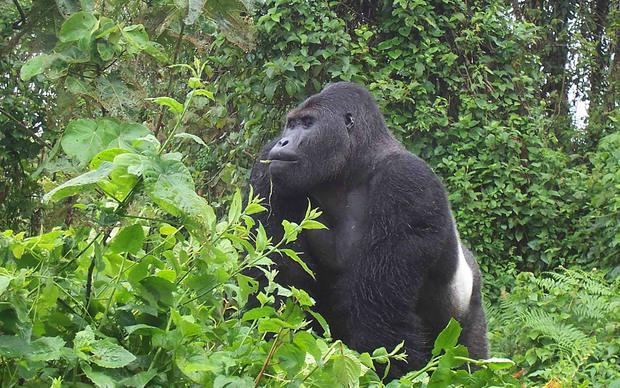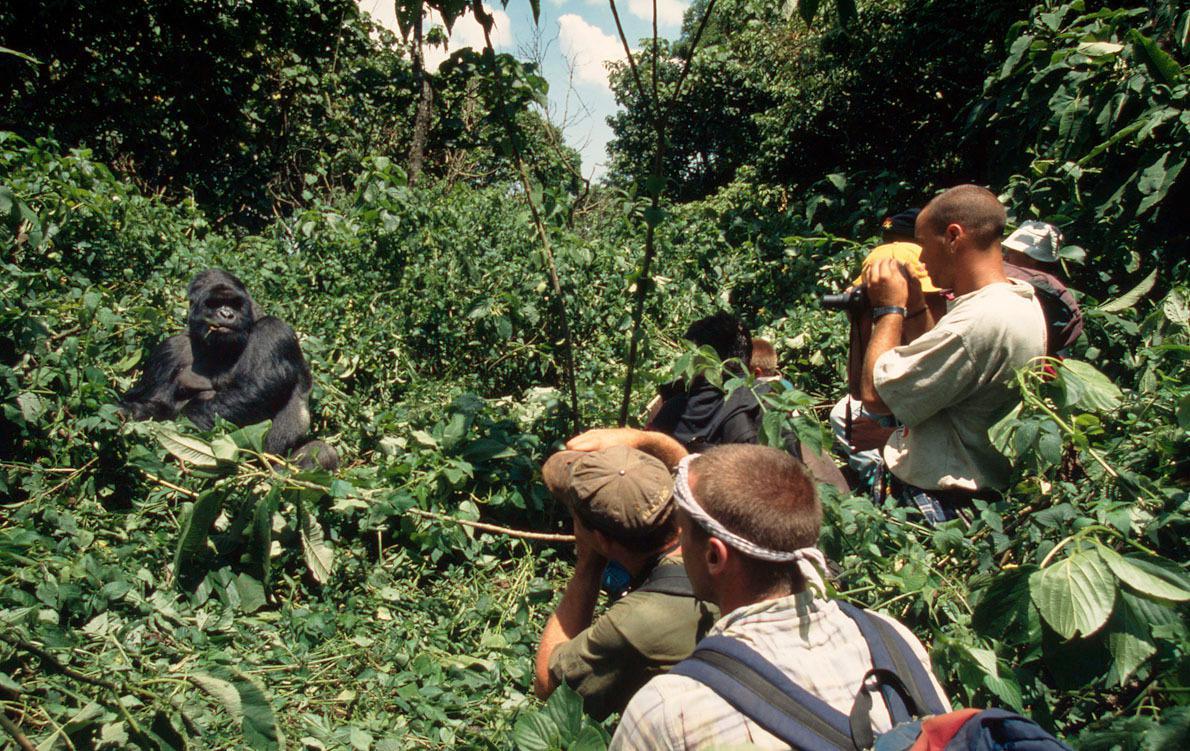The first image is the image on the left, the second image is the image on the right. Assess this claim about the two images: "One image shows a single ape lying upside-down on its back, with the top of its head facing the camera.". Correct or not? Answer yes or no. No. The first image is the image on the left, the second image is the image on the right. Given the left and right images, does the statement "The right image contains exactly one gorilla laying on its back surrounded by green foliage." hold true? Answer yes or no. No. 